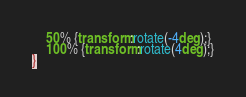Convert code to text. <code><loc_0><loc_0><loc_500><loc_500><_CSS_>	50% {transform:rotate(-4deg);}
	100% {transform:rotate(4deg);}
}</code> 